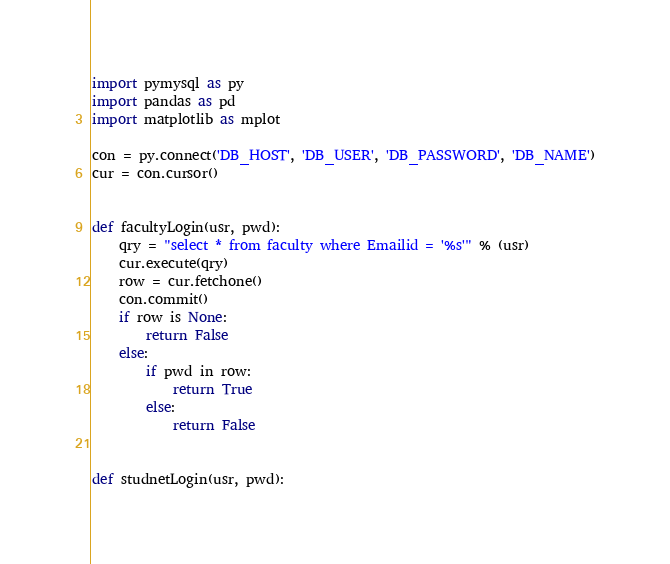<code> <loc_0><loc_0><loc_500><loc_500><_Python_>import pymysql as py
import pandas as pd
import matplotlib as mplot

con = py.connect('DB_HOST', 'DB_USER', 'DB_PASSWORD', 'DB_NAME')
cur = con.cursor()


def facultyLogin(usr, pwd):
    qry = "select * from faculty where Emailid = '%s'" % (usr)
    cur.execute(qry)
    row = cur.fetchone()
    con.commit()
    if row is None:
        return False
    else:
        if pwd in row:
            return True
        else:
            return False


def studnetLogin(usr, pwd):</code> 